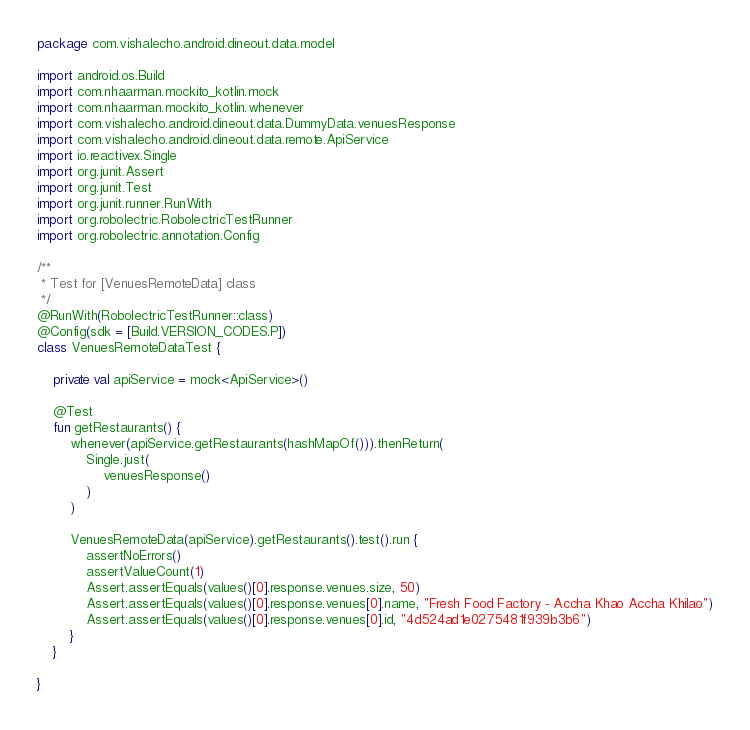Convert code to text. <code><loc_0><loc_0><loc_500><loc_500><_Kotlin_>package com.vishalecho.android.dineout.data.model

import android.os.Build
import com.nhaarman.mockito_kotlin.mock
import com.nhaarman.mockito_kotlin.whenever
import com.vishalecho.android.dineout.data.DummyData.venuesResponse
import com.vishalecho.android.dineout.data.remote.ApiService
import io.reactivex.Single
import org.junit.Assert
import org.junit.Test
import org.junit.runner.RunWith
import org.robolectric.RobolectricTestRunner
import org.robolectric.annotation.Config

/**
 * Test for [VenuesRemoteData] class
 */
@RunWith(RobolectricTestRunner::class)
@Config(sdk = [Build.VERSION_CODES.P])
class VenuesRemoteDataTest {

    private val apiService = mock<ApiService>()

    @Test
    fun getRestaurants() {
        whenever(apiService.getRestaurants(hashMapOf())).thenReturn(
            Single.just(
                venuesResponse()
            )
        )

        VenuesRemoteData(apiService).getRestaurants().test().run {
            assertNoErrors()
            assertValueCount(1)
            Assert.assertEquals(values()[0].response.venues.size, 50)
            Assert.assertEquals(values()[0].response.venues[0].name, "Fresh Food Factory - Accha Khao Accha Khilao")
            Assert.assertEquals(values()[0].response.venues[0].id, "4d524ad1e0275481f939b3b6")
        }
    }

}</code> 